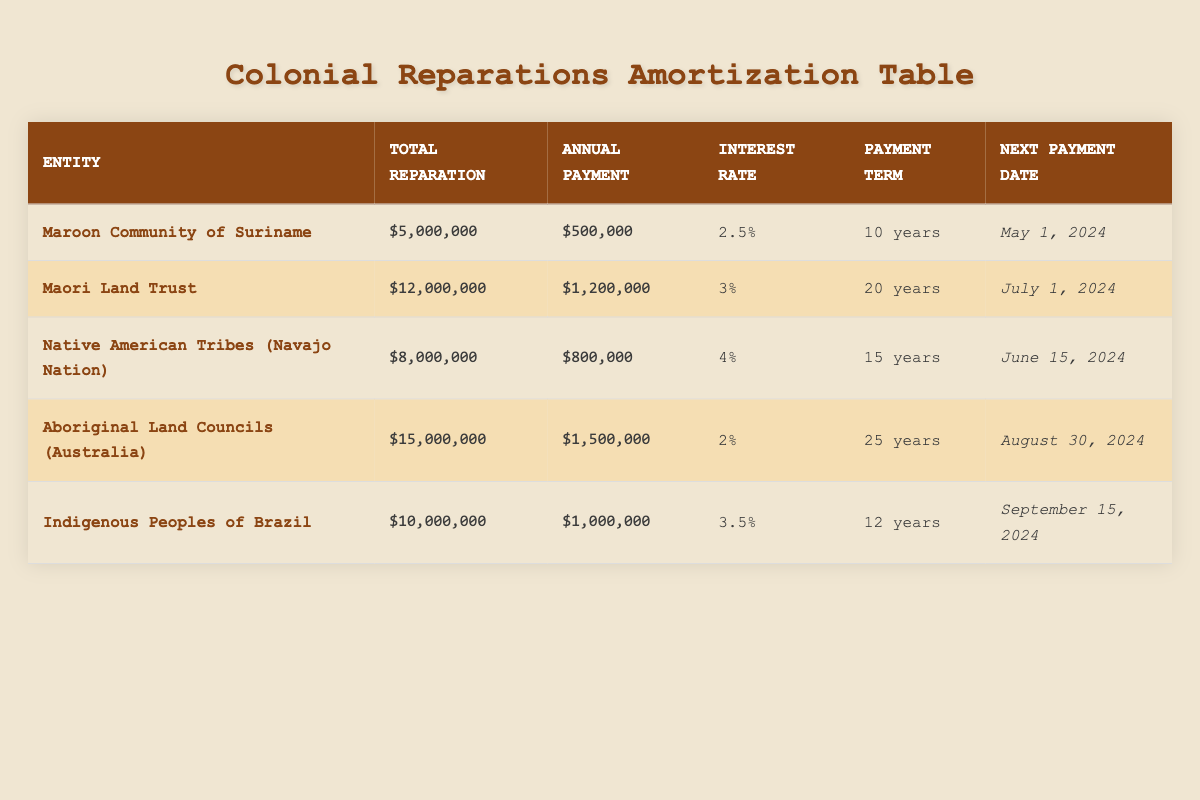What is the total reparation amount for the Maroon Community of Suriname? The table lists the total reparation amount for the Maroon Community of Suriname as $5,000,000.
Answer: $5,000,000 How many years is the repayment term for the Maori Land Trust? Looking at the table, the repayment term for the Maori Land Trust is specified as 20 years.
Answer: 20 years What is the annual payment amount for Indigenous Peoples of Brazil? The annual payment amount for Indigenous Peoples of Brazil is shown as $1,000,000 in the table.
Answer: $1,000,000 Are the annual payments for the Aboriginal Land Councils (Australia) greater than those for the Native American Tribes (Navajo Nation)? The annual payment for Aboriginal Land Councils is $1,500,000, while the payment for Native American Tribes is $800,000. Since $1,500,000 is greater than $800,000, the statement is true.
Answer: Yes Which entity has the highest total reparation amount? The total reparation amounts in the table list the Aboriginal Land Councils as having $15,000,000, which is higher than any other entity's amount. Thus, the answer is Aboriginal Land Councils (Australia).
Answer: Aboriginal Land Councils (Australia) What is the average annual payment across all entities listed in the table? To find the average annual payment, we first sum the annual payments: $500,000 + $1,200,000 + $800,000 + $1,500,000 + $1,000,000 = $5,000,000. Then, divide by the number of entities (5): $5,000,000 / 5 = $1,000,000.
Answer: $1,000,000 Is the interest rate for the Native American Tribes higher than that for the Maroon Community? The interest rate for Native American Tribes is 4% while for the Maroon Community it is 2.5%. Since 4% is greater than 2.5%, the statement is true.
Answer: Yes If the next payment date for the Maori Land Trust is July 1, 2024, when is the next payment for the Aboriginal Land Councils? The next payment date for the Aboriginal Land Councils is listed as August 30, 2024, which comes after July 1, 2024. Hence, if we are comparing the two payment dates, the Aboriginal Land Councils' next payment is later.
Answer: August 30, 2024 What is the difference in total reparation amounts between the highest and lowest entity? The highest total reparation amount is $15,000,000 (Aboriginal Land Councils) and the lowest is $5,000,000 (Maroon Community). Therefore, the difference is $15,000,000 - $5,000,000 = $10,000,000.
Answer: $10,000,000 